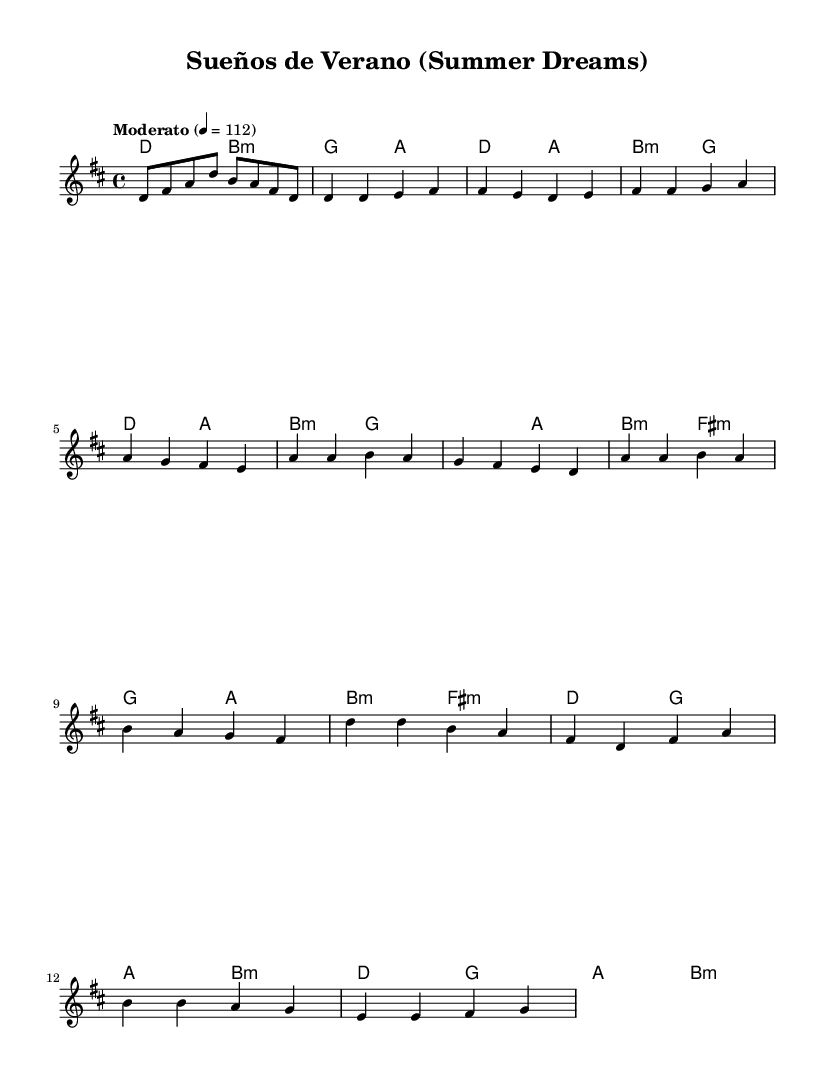What is the key signature of this music? The key signature is D major, which has two sharps (F# and C#). This is determined from the initial section of the sheet music where the key is indicated.
Answer: D major What is the time signature of this music? The time signature is 4/4, which is seen at the beginning of the sheet music. This indicates there are four beats in each measure and a quarter note gets one beat.
Answer: 4/4 What is the tempo marking for this piece? The tempo marking is "Moderato," which suggests a moderate pace. This is explicitly mentioned at the start of the music, indicating how fast it should be played.
Answer: Moderato How many measures are there in the chorus section? The chorus section consists of four measures, as can be counted by looking at the notation provided in the sheet music specifically for that section.
Answer: 4 What is the first note of the melody? The first note of the melody is D. This note can be identified at the beginning of the melody line, which starts on the note D in the staff.
Answer: D Which chords are used in the pre-chorus? The chords used in the pre-chorus are G, A, B minor, and F sharp minor. This can be determined by examining the chord symbols directly above the melody in the pre-chorus section of the sheet music.
Answer: G, A, B minor, F sharp minor 